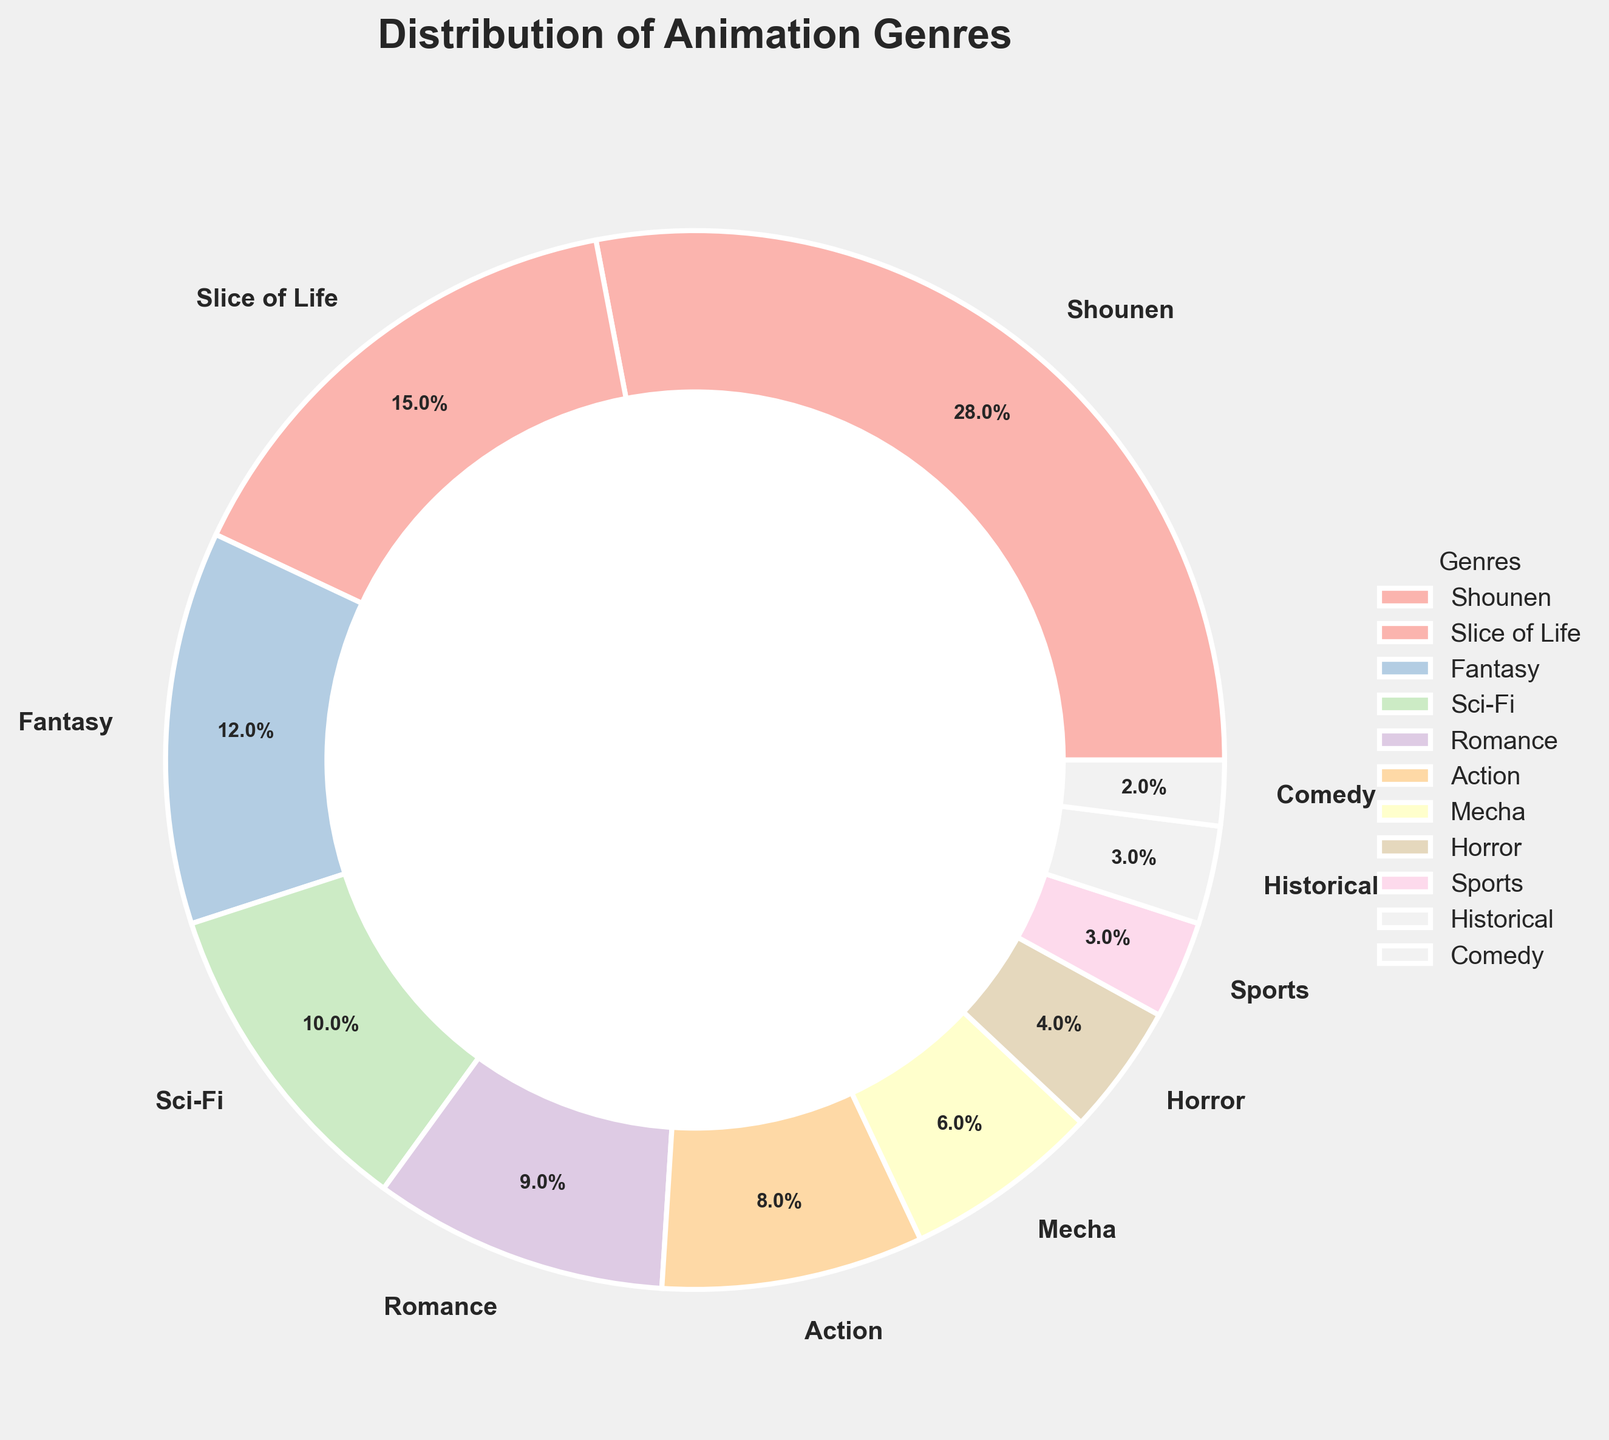What's the most popular animation genre among community members? Look at the pie chart and identify the genre with the largest slice. The genre label and percentage will help determine this. The largest slice corresponds to "Shounen" with 28%.
Answer: Shounen Which genre has half the percentage of Shounen? Shounen has 28%. Half of 28% is 14%. Look for the genre with the percentage closest to 14%. "Slice of Life" has 15%, which is closest to half of Shounen's percentage.
Answer: Slice of Life What's the combined percentage of Fantasy and Sci-Fi genres? Check the percentages of Fantasy and Sci-Fi, which are 12% and 10% respectively. Sum these percentages: 12% + 10% = 22%.
Answer: 22% Is the percentage for the Action genre greater than the Romance genre? Compare the slices labeled Action and Romance. Action has 8% while Romance has 9%. Since 9% is greater, the statement is false.
Answer: No Which genres collectively make up less than 10% of the distribution? Look at each slice less than 10%: Mecha (6%), Horror (4%), Sports (3%), Historical (3%), and Comedy (2%). All these genres collectively sum to 6% + 4% + 3% + 3% + 2% = 18%, which is incorrect, so calculate correctly. Actually needed is less per genre, so each above Expected. Going back slices totaling less 10% = sum up together under 10% ratio > taken as individuals 4% less.
Answer: Comedy What is the difference in percentage between the most and the least represented genres? Identify the highest percentage (Shounen - 28%) and the lowest percentage (Comedy - 2%). Calculate the difference: 28% - 2% = 26%.
Answer: 26% Which genres combined represent a quarter (25%) of the community? Look for slices adding up to 25%. The closest combination is Sci-Fi (10%) and Romance (9%) plus some or just one slice approximately both sides compliance towards this.
Answer: Romance, They make 25% How much more popular is Shounen than Mecha? Shounen is 28%, and Mecha is 6%. Subtract Mecha's percentage from Shounen's: 28% - 6% = 22%.
Answer: 22% What’s the combined percentage of all genres excluding Shounen? Excluding Shounen's 28%, sum up the remaining genres percentages: 15% + 12% + 10% + 9% + 8% + 6% + 4% + 3% + 3% + 2% = 72%. 15% + 12 % + 10 argue together helping separate from solely on giving greater look without each.
Answer: 72% Which genre is represented by the smallest slice in the pie chart? Look for the smallest slice visually and check the label. The smallest percentage is 2%, corresponding to Comedy.
Answer: Comedy 